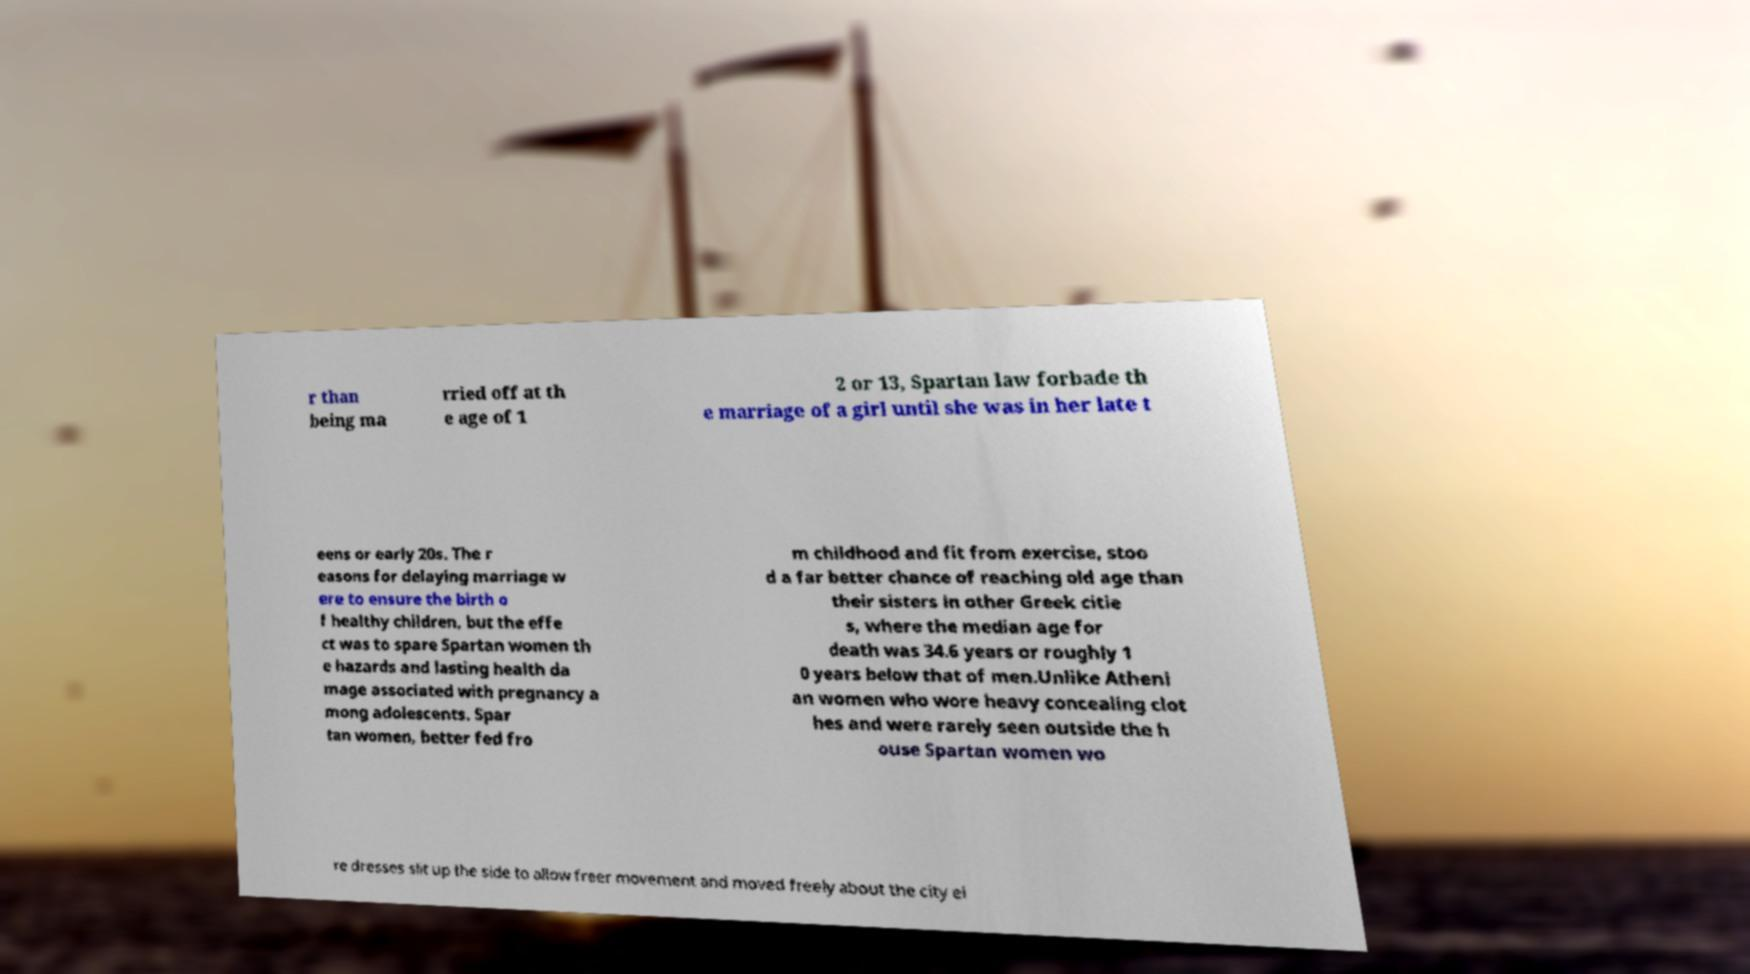For documentation purposes, I need the text within this image transcribed. Could you provide that? r than being ma rried off at th e age of 1 2 or 13, Spartan law forbade th e marriage of a girl until she was in her late t eens or early 20s. The r easons for delaying marriage w ere to ensure the birth o f healthy children, but the effe ct was to spare Spartan women th e hazards and lasting health da mage associated with pregnancy a mong adolescents. Spar tan women, better fed fro m childhood and fit from exercise, stoo d a far better chance of reaching old age than their sisters in other Greek citie s, where the median age for death was 34.6 years or roughly 1 0 years below that of men.Unlike Atheni an women who wore heavy concealing clot hes and were rarely seen outside the h ouse Spartan women wo re dresses slit up the side to allow freer movement and moved freely about the city ei 